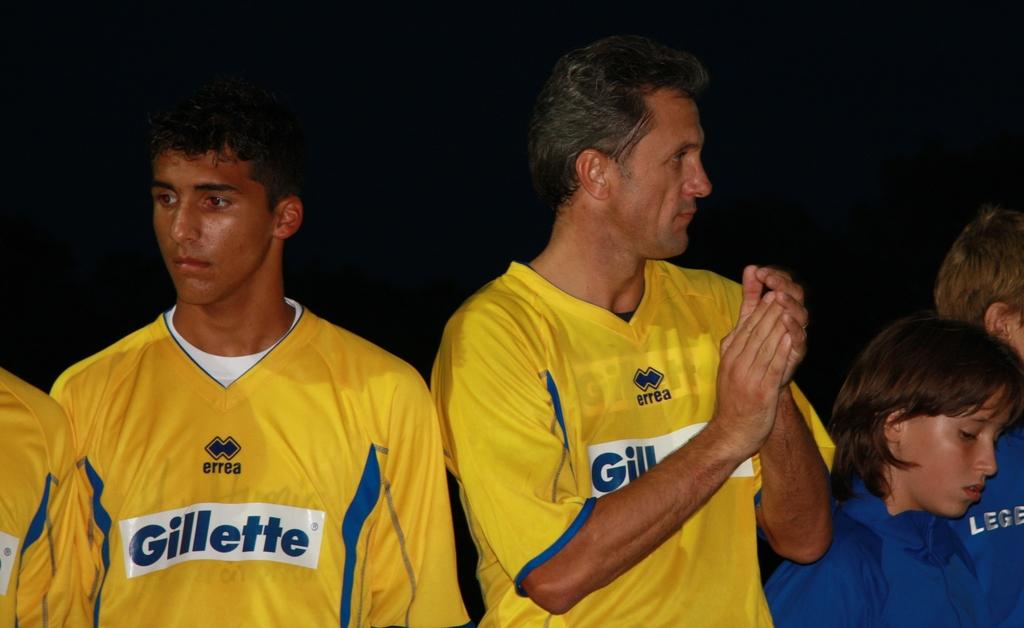What clothing brand are the yellow jerseys?
Provide a succinct answer. Errea. 